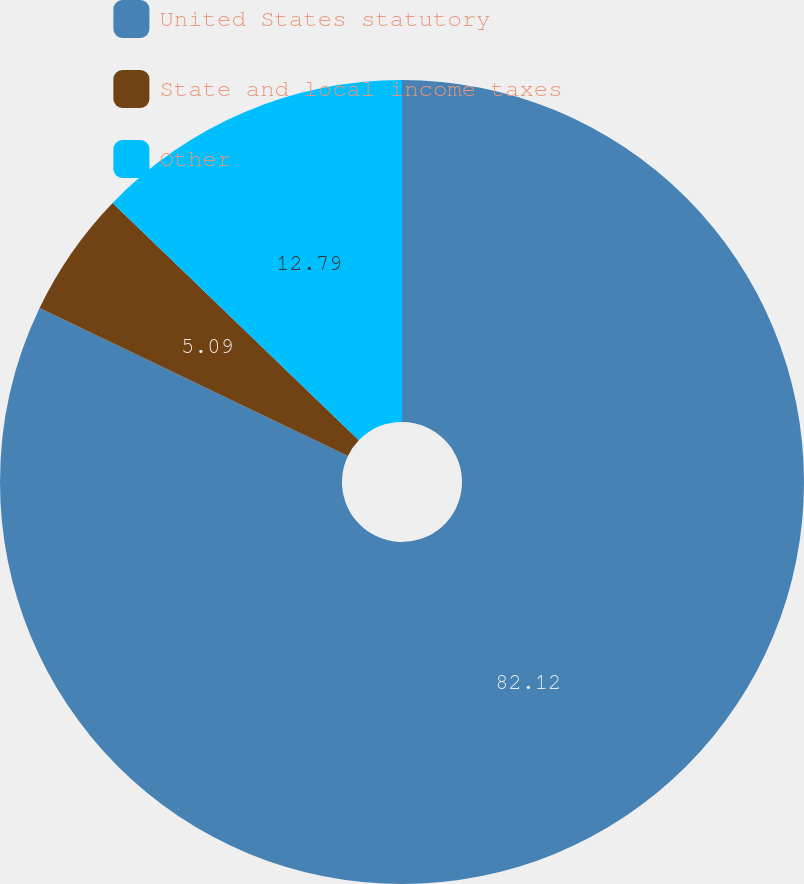Convert chart. <chart><loc_0><loc_0><loc_500><loc_500><pie_chart><fcel>United States statutory<fcel>State and local income taxes<fcel>Other<nl><fcel>82.12%<fcel>5.09%<fcel>12.79%<nl></chart> 